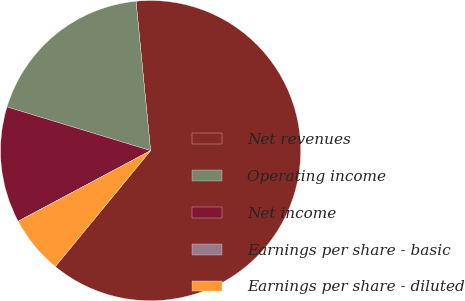Convert chart. <chart><loc_0><loc_0><loc_500><loc_500><pie_chart><fcel>Net revenues<fcel>Operating income<fcel>Net income<fcel>Earnings per share - basic<fcel>Earnings per share - diluted<nl><fcel>62.5%<fcel>18.75%<fcel>12.5%<fcel>0.0%<fcel>6.25%<nl></chart> 